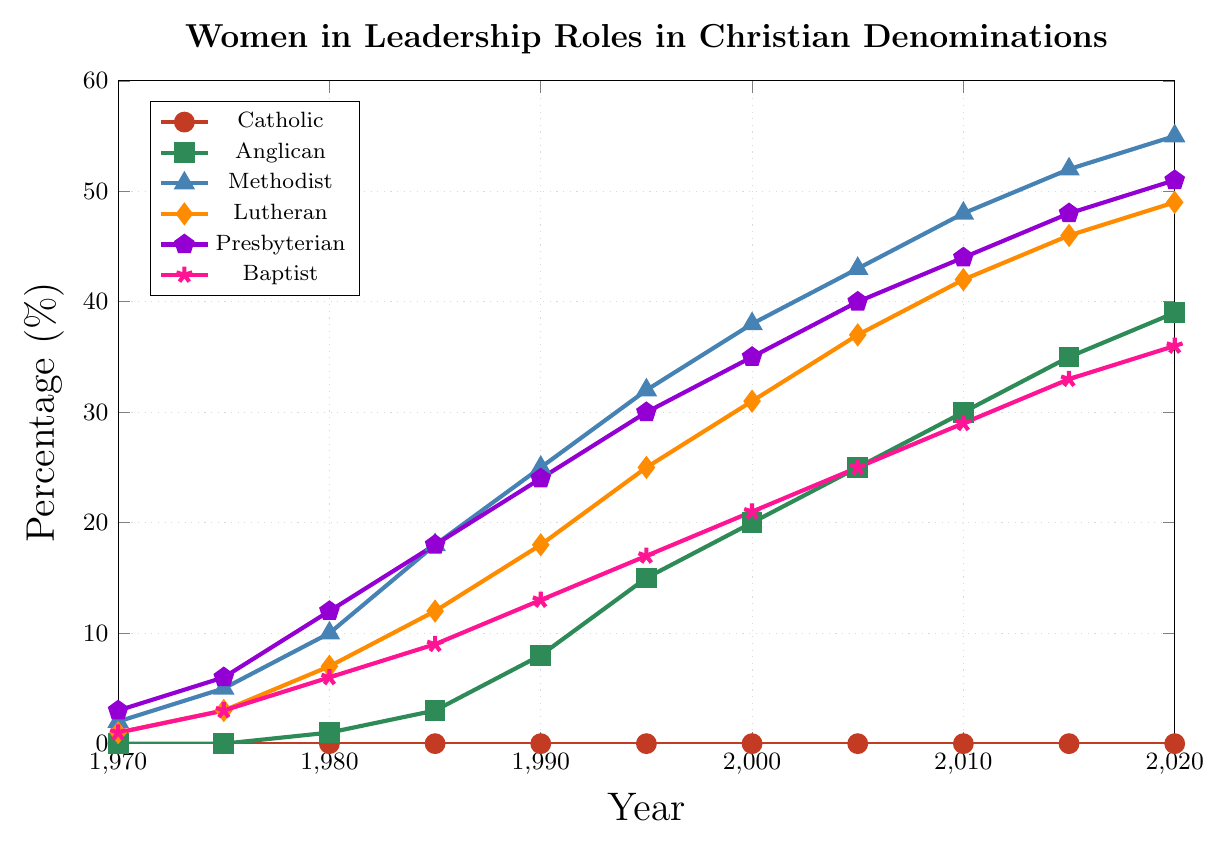What percentage of women in leadership roles did the Presbyterian denomination have in 1990? Look at the line representing the Presbyterian denomination and find the value at the year 1990. The value is 24%.
Answer: 24% Between Baptist and Methodist, which denomination had a higher percentage of women in leadership roles in 2000, and by how much? Compare the values for Baptist and Methodist in the year 2000. Methodist had 38%, and Baptist had 21%, so Methodist had 17% more.
Answer: Methodist by 17% What is the average percentage of women in leadership roles in the Lutheran denomination from 1985 to 2000? Calculate the average of values at 1985, 1990, 1995, and 2000 for the Lutheran denomination: (12 + 18 + 25 + 31) / 4 = 21.5%.
Answer: 21.5% Has the percentage of women in leadership roles in the Anglican denomination ever exceeded that of the Baptist denomination, and if so, in what year did this first occur? Compare the values for Anglican and Baptist denominations in each year. Anglican first exceeds Baptist in 1990 with percentages of 8% and 13% respectively.
Answer: No, it occurred in 1995 In what year did the percentage of women in leadership roles in the Anglican denomination reach 20%? Refer to the line for the Anglican denomination and check when it hits 20%. This occurred in 2000.
Answer: 2000 How many denominations had no women in leadership roles in 1980? Look at the values in 1980 for each denomination. Catholic had 0%, Anglican had 1%, Methodist had 10%, Lutheran had 7%, Presbyterian had 12%, and Baptist had 6%. Only Catholic had 0%.
Answer: 1 